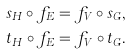Convert formula to latex. <formula><loc_0><loc_0><loc_500><loc_500>s _ { H } \circ f _ { E } = f _ { V } \circ s _ { G } , \\ t _ { H } \circ f _ { E } = f _ { V } \circ t _ { G } .</formula> 